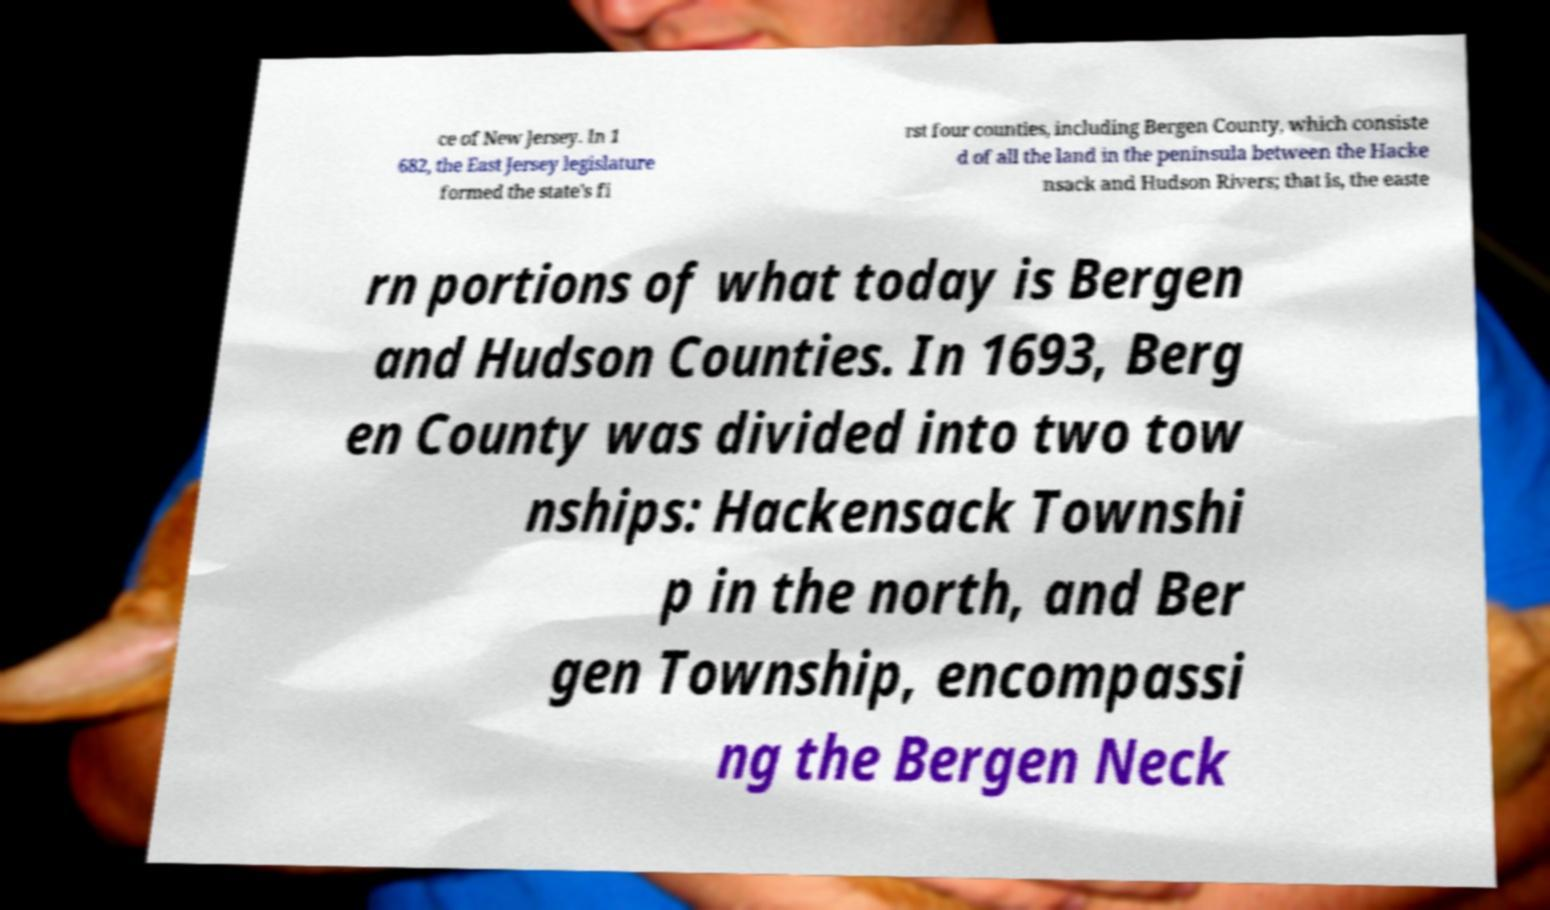Could you assist in decoding the text presented in this image and type it out clearly? ce of New Jersey. In 1 682, the East Jersey legislature formed the state's fi rst four counties, including Bergen County, which consiste d of all the land in the peninsula between the Hacke nsack and Hudson Rivers; that is, the easte rn portions of what today is Bergen and Hudson Counties. In 1693, Berg en County was divided into two tow nships: Hackensack Townshi p in the north, and Ber gen Township, encompassi ng the Bergen Neck 